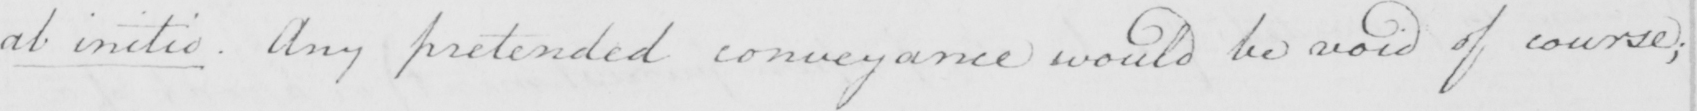Transcribe the text shown in this historical manuscript line. ab initio . Any pretended conveyance would be void of course ; 